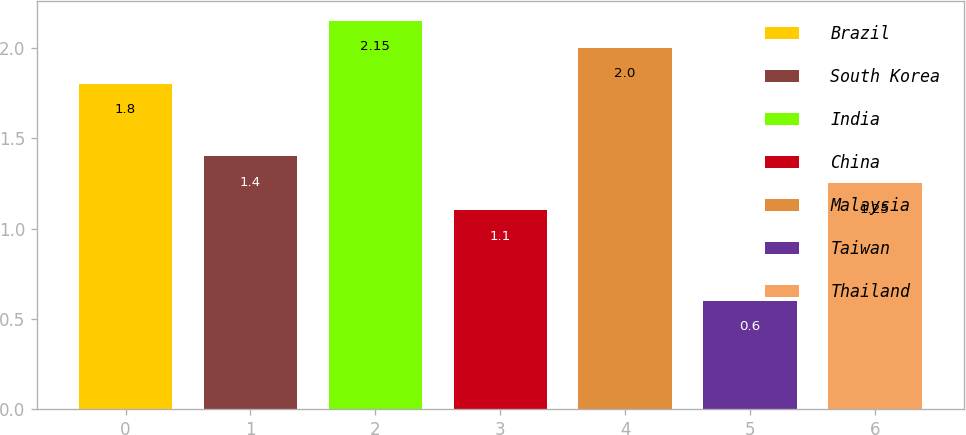<chart> <loc_0><loc_0><loc_500><loc_500><bar_chart><fcel>Brazil<fcel>South Korea<fcel>India<fcel>China<fcel>Malaysia<fcel>Taiwan<fcel>Thailand<nl><fcel>1.8<fcel>1.4<fcel>2.15<fcel>1.1<fcel>2<fcel>0.6<fcel>1.25<nl></chart> 